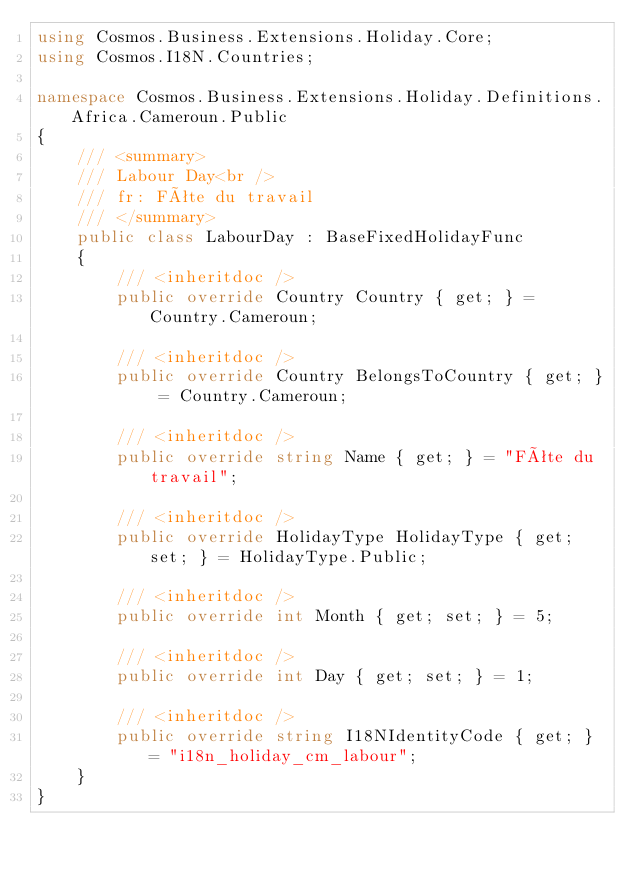<code> <loc_0><loc_0><loc_500><loc_500><_C#_>using Cosmos.Business.Extensions.Holiday.Core;
using Cosmos.I18N.Countries;

namespace Cosmos.Business.Extensions.Holiday.Definitions.Africa.Cameroun.Public
{
    /// <summary>
    /// Labour Day<br />
    /// fr: Fête du travail
    /// </summary>
    public class LabourDay : BaseFixedHolidayFunc
    {
        /// <inheritdoc />
        public override Country Country { get; } = Country.Cameroun;

        /// <inheritdoc />
        public override Country BelongsToCountry { get; } = Country.Cameroun;

        /// <inheritdoc />
        public override string Name { get; } = "Fête du travail";

        /// <inheritdoc />
        public override HolidayType HolidayType { get; set; } = HolidayType.Public;

        /// <inheritdoc />
        public override int Month { get; set; } = 5;

        /// <inheritdoc />
        public override int Day { get; set; } = 1;

        /// <inheritdoc />
        public override string I18NIdentityCode { get; } = "i18n_holiday_cm_labour";
    }
}</code> 